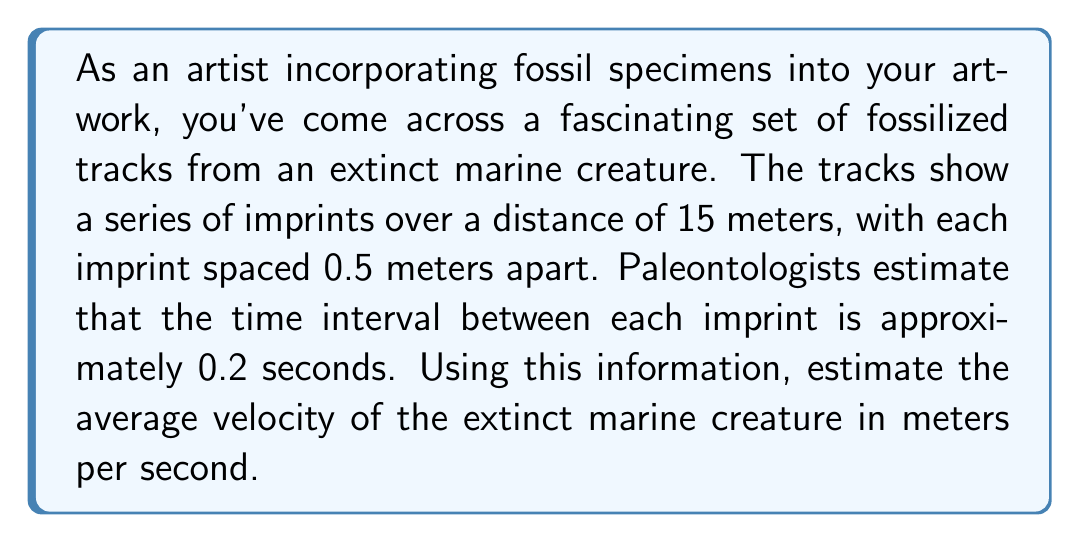Solve this math problem. To solve this problem, we'll use the basic formula for average velocity:

$$v = \frac{\Delta x}{\Delta t}$$

Where:
$v$ = average velocity
$\Delta x$ = change in position (distance traveled)
$\Delta t$ = change in time

Step 1: Calculate the total distance traveled
- Total distance = 15 meters

Step 2: Calculate the total time taken
- Number of intervals = $\frac{15 \text{ m}}{0.5 \text{ m/interval}} = 30$ intervals
- Total time = 30 intervals × 0.2 seconds/interval = 6 seconds

Step 3: Apply the average velocity formula
$$v = \frac{\Delta x}{\Delta t} = \frac{15 \text{ m}}{6 \text{ s}} = 2.5 \text{ m/s}$$

Therefore, the estimated average velocity of the extinct marine creature is 2.5 meters per second.
Answer: $2.5 \text{ m/s}$ 